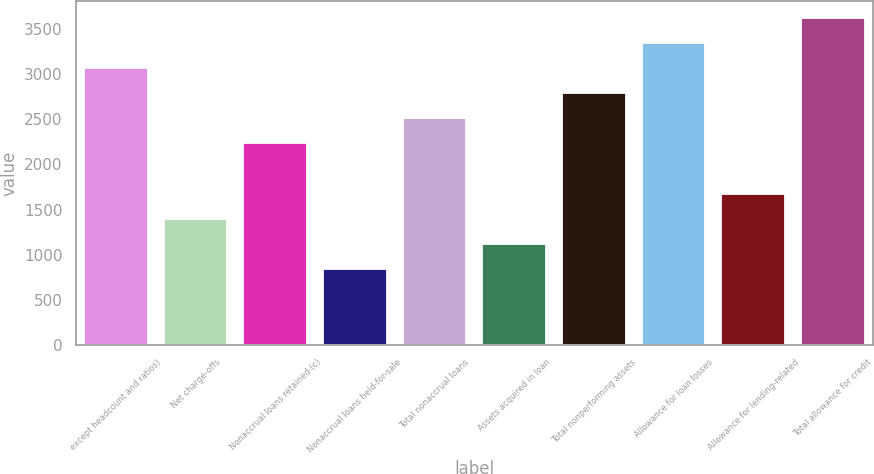Convert chart to OTSL. <chart><loc_0><loc_0><loc_500><loc_500><bar_chart><fcel>except headcount and ratios)<fcel>Net charge-offs<fcel>Nonaccrual loans retained (c)<fcel>Nonaccrual loans held-for-sale<fcel>Total nonaccrual loans<fcel>Assets acquired in loan<fcel>Total nonperforming assets<fcel>Allowance for loan losses<fcel>Allowance for lending-related<fcel>Total allowance for credit<nl><fcel>3071.16<fcel>1396.08<fcel>2233.62<fcel>837.72<fcel>2512.8<fcel>1116.9<fcel>2791.98<fcel>3350.34<fcel>1675.26<fcel>3629.52<nl></chart> 